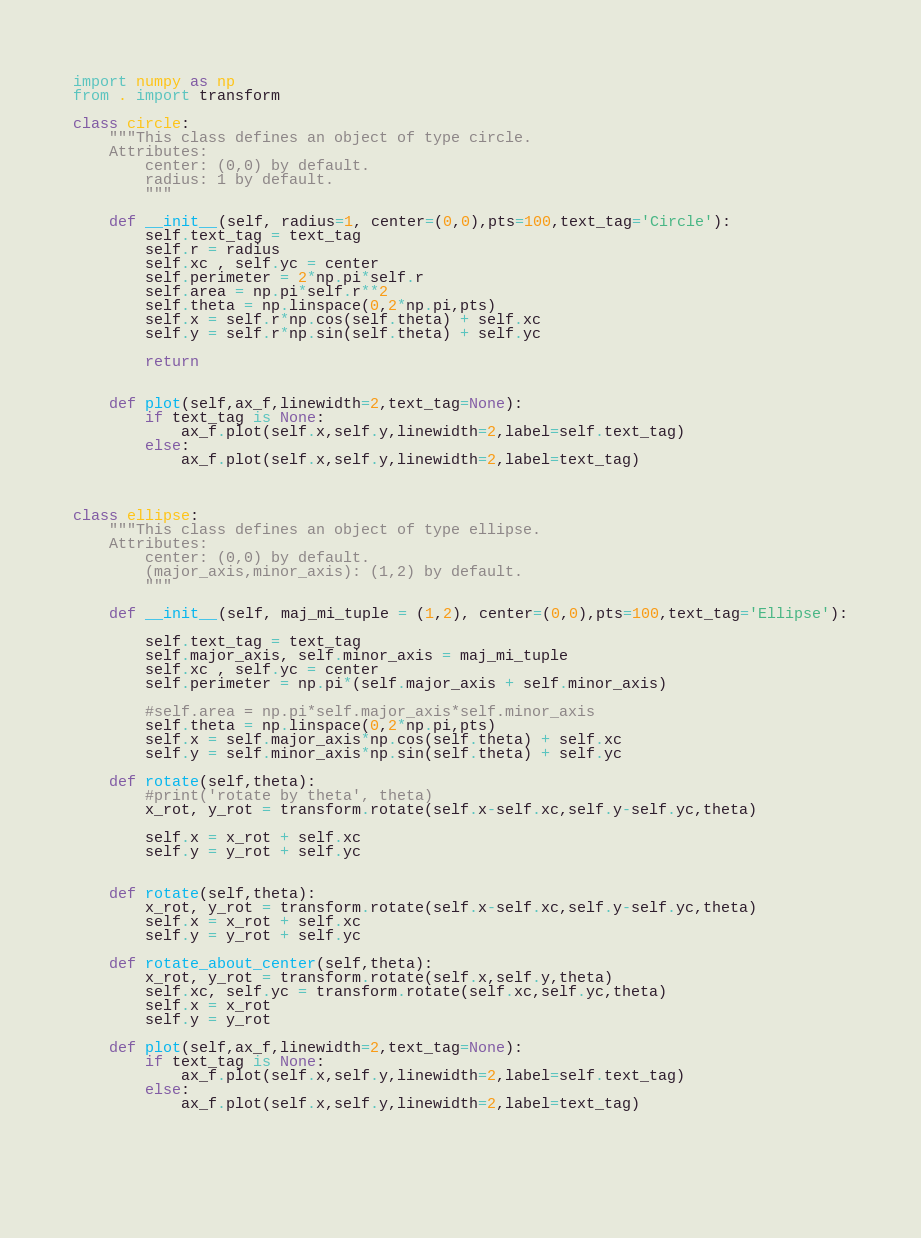Convert code to text. <code><loc_0><loc_0><loc_500><loc_500><_Python_>import numpy as np
from . import transform

class circle:
	"""This class defines an object of type circle. 
	Attributes: 
		center: (0,0) by default.
		radius: 1 by default.
		"""
	
	def __init__(self, radius=1, center=(0,0),pts=100,text_tag='Circle'):
		self.text_tag = text_tag
		self.r = radius
		self.xc , self.yc = center
		self.perimeter = 2*np.pi*self.r
		self.area = np.pi*self.r**2
		self.theta = np.linspace(0,2*np.pi,pts)
		self.x = self.r*np.cos(self.theta) + self.xc
		self.y = self.r*np.sin(self.theta) + self.yc
		
		return
		
		
	def plot(self,ax_f,linewidth=2,text_tag=None):
		if text_tag is None:
			ax_f.plot(self.x,self.y,linewidth=2,label=self.text_tag)
		else:
			ax_f.plot(self.x,self.y,linewidth=2,label=text_tag)
			


class ellipse:
	"""This class defines an object of type ellipse.
	Attributes: 
		center: (0,0) by default.
		(major_axis,minor_axis): (1,2) by default. 
		"""
	
	def __init__(self, maj_mi_tuple = (1,2), center=(0,0),pts=100,text_tag='Ellipse'):
		
		self.text_tag = text_tag
		self.major_axis, self.minor_axis = maj_mi_tuple
		self.xc , self.yc = center
		self.perimeter = np.pi*(self.major_axis + self.minor_axis)
		
		#self.area = np.pi*self.major_axis*self.minor_axis
		self.theta = np.linspace(0,2*np.pi,pts)
		self.x = self.major_axis*np.cos(self.theta) + self.xc
		self.y = self.minor_axis*np.sin(self.theta) + self.yc
		
	def rotate(self,theta):
		#print('rotate by theta', theta)
		x_rot, y_rot = transform.rotate(self.x-self.xc,self.y-self.yc,theta)
		
		self.x = x_rot + self.xc
		self.y = y_rot + self.yc
		
		
	def rotate(self,theta):
		x_rot, y_rot = transform.rotate(self.x-self.xc,self.y-self.yc,theta)
		self.x = x_rot + self.xc
		self.y = y_rot + self.yc
		
	def rotate_about_center(self,theta):
		x_rot, y_rot = transform.rotate(self.x,self.y,theta)
		self.xc, self.yc = transform.rotate(self.xc,self.yc,theta)
		self.x = x_rot
		self.y = y_rot
		
	def plot(self,ax_f,linewidth=2,text_tag=None):
		if text_tag is None:
			ax_f.plot(self.x,self.y,linewidth=2,label=self.text_tag)
		else:
			ax_f.plot(self.x,self.y,linewidth=2,label=text_tag)
			

		
		



</code> 